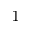<formula> <loc_0><loc_0><loc_500><loc_500>^ { 1 }</formula> 